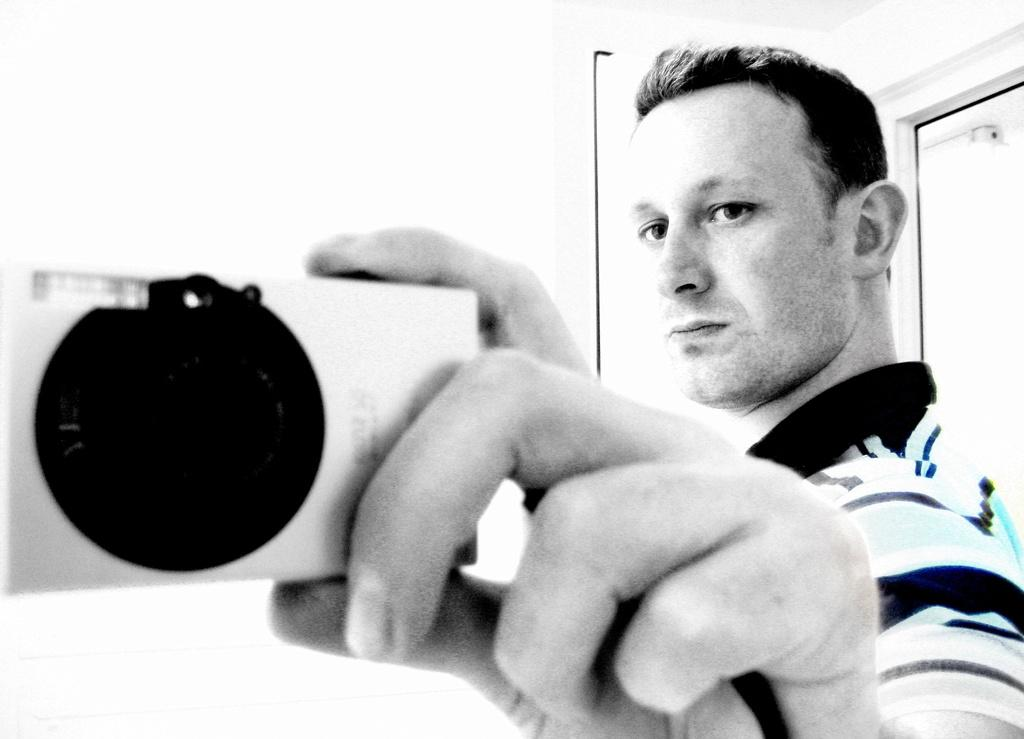Who is the main subject in the foreground of the image? There is a man in the foreground of the image. What is the man doing in the image? The man is standing in the image. What is the man holding in the image? The man is holding a camera in the image. What can be seen in the background of the image? There is a door and a wall in the background of the image. What type of game is the man playing in the image? There is no game present in the image; the man is holding a camera. What color is the flag in the image? There is no flag present in the image. 